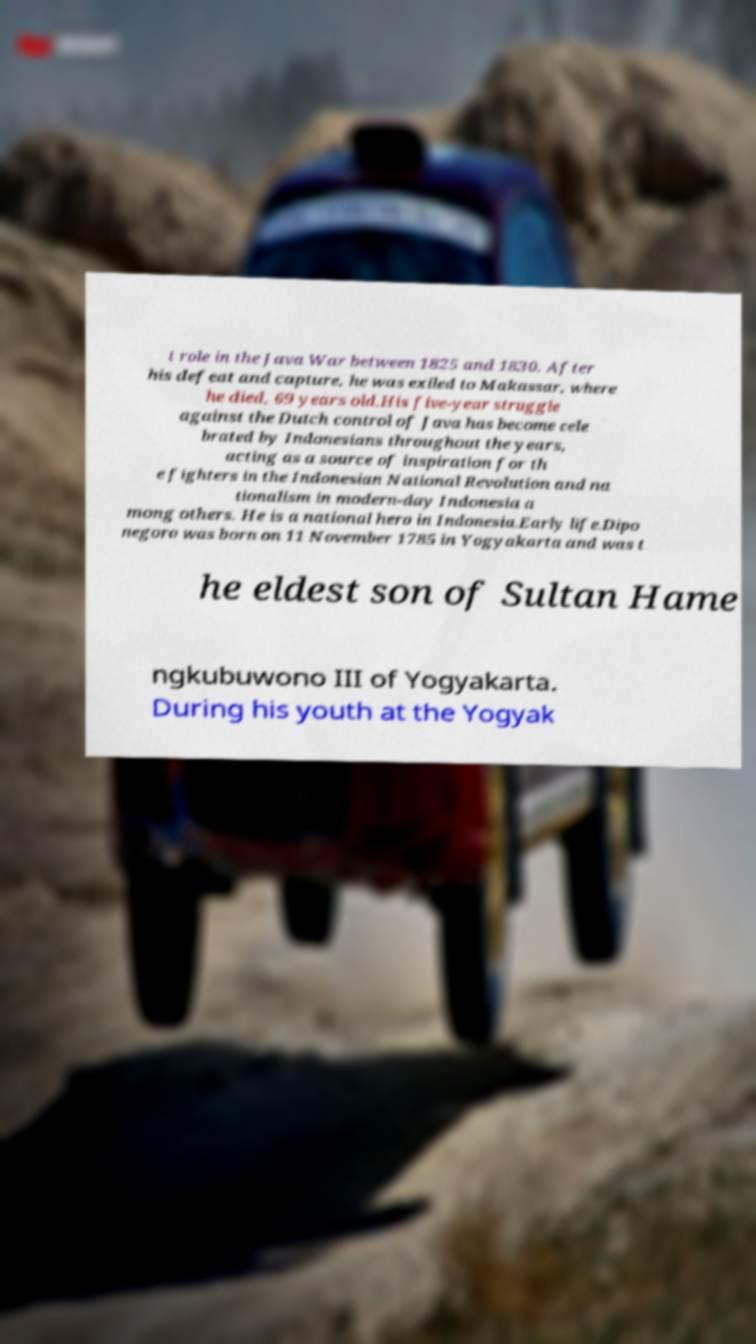Could you assist in decoding the text presented in this image and type it out clearly? t role in the Java War between 1825 and 1830. After his defeat and capture, he was exiled to Makassar, where he died, 69 years old.His five-year struggle against the Dutch control of Java has become cele brated by Indonesians throughout the years, acting as a source of inspiration for th e fighters in the Indonesian National Revolution and na tionalism in modern-day Indonesia a mong others. He is a national hero in Indonesia.Early life.Dipo negoro was born on 11 November 1785 in Yogyakarta and was t he eldest son of Sultan Hame ngkubuwono III of Yogyakarta. During his youth at the Yogyak 